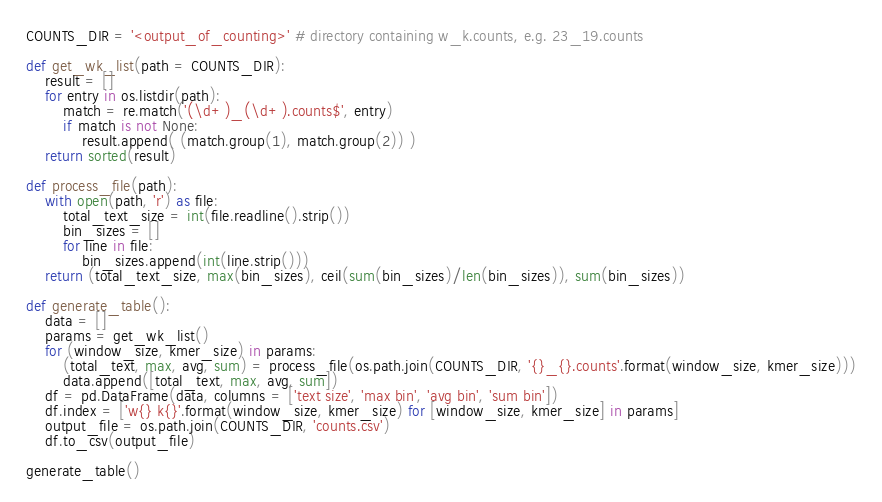Convert code to text. <code><loc_0><loc_0><loc_500><loc_500><_Python_>COUNTS_DIR = '<output_of_counting>' # directory containing w_k.counts, e.g. 23_19.counts

def get_wk_list(path = COUNTS_DIR):
    result = []
    for entry in os.listdir(path):
        match = re.match('(\d+)_(\d+).counts$', entry)
        if match is not None:
            result.append( (match.group(1), match.group(2)) )
    return sorted(result)

def process_file(path):
    with open(path, 'r') as file:
        total_text_size = int(file.readline().strip())
        bin_sizes = []
        for line in file:
            bin_sizes.append(int(line.strip()))
    return (total_text_size, max(bin_sizes), ceil(sum(bin_sizes)/len(bin_sizes)), sum(bin_sizes))

def generate_table():
    data = []
    params = get_wk_list()
    for (window_size, kmer_size) in params:
        (total_text, max, avg, sum) = process_file(os.path.join(COUNTS_DIR, '{}_{}.counts'.format(window_size, kmer_size)))
        data.append([total_text, max, avg, sum])
    df = pd.DataFrame(data, columns = ['text size', 'max bin', 'avg bin', 'sum bin'])
    df.index = ['w{} k{}'.format(window_size, kmer_size) for [window_size, kmer_size] in params]
    output_file = os.path.join(COUNTS_DIR, 'counts.csv')
    df.to_csv(output_file)

generate_table()
</code> 